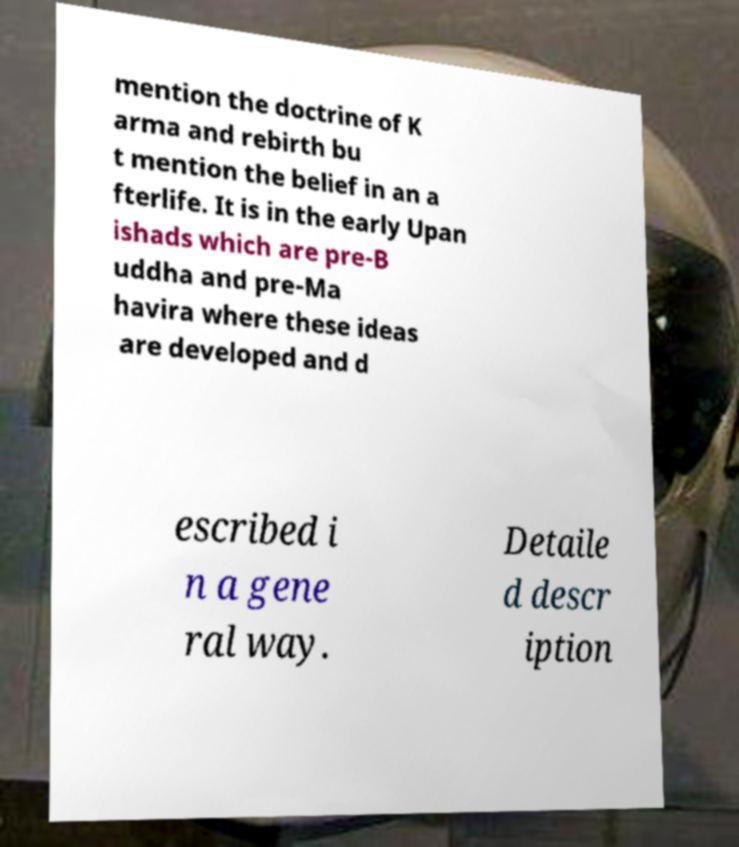Can you accurately transcribe the text from the provided image for me? mention the doctrine of K arma and rebirth bu t mention the belief in an a fterlife. It is in the early Upan ishads which are pre-B uddha and pre-Ma havira where these ideas are developed and d escribed i n a gene ral way. Detaile d descr iption 